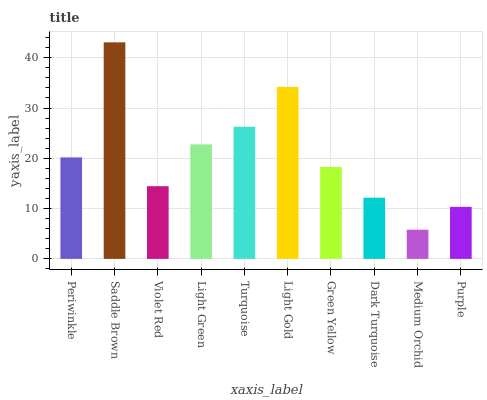Is Medium Orchid the minimum?
Answer yes or no. Yes. Is Saddle Brown the maximum?
Answer yes or no. Yes. Is Violet Red the minimum?
Answer yes or no. No. Is Violet Red the maximum?
Answer yes or no. No. Is Saddle Brown greater than Violet Red?
Answer yes or no. Yes. Is Violet Red less than Saddle Brown?
Answer yes or no. Yes. Is Violet Red greater than Saddle Brown?
Answer yes or no. No. Is Saddle Brown less than Violet Red?
Answer yes or no. No. Is Periwinkle the high median?
Answer yes or no. Yes. Is Green Yellow the low median?
Answer yes or no. Yes. Is Light Gold the high median?
Answer yes or no. No. Is Light Gold the low median?
Answer yes or no. No. 